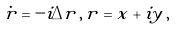<formula> <loc_0><loc_0><loc_500><loc_500>\dot { r } = - i \Delta r \, , \, r = x + i y \, ,</formula> 